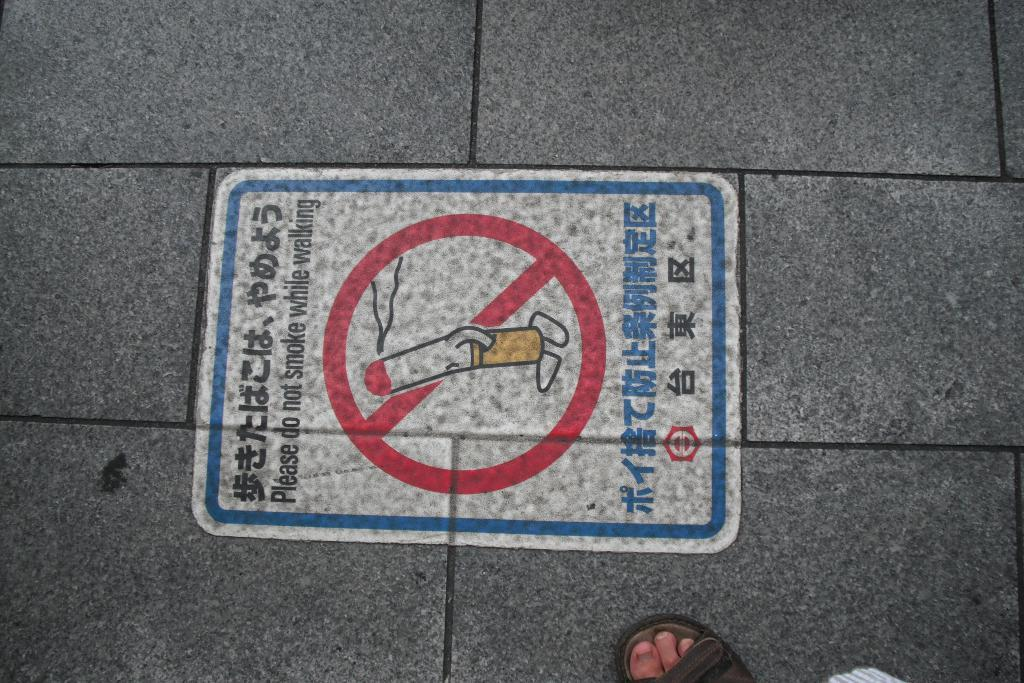What object can be seen on the floor in the image? There is a sign board on the floor in the image. Can you describe any other elements on the floor in the image? A person's leg is visible on the floor in the image. How many deer can be seen grazing in the image? There are no deer present in the image. What type of paste is being used by the person in the image? There is: There is no indication of any paste being used in the image. 